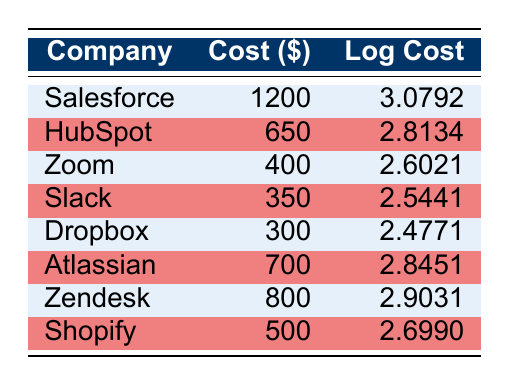What is the customer acquisition cost for Salesforce? By referring to the table, we look for the row that includes Salesforce. The customer acquisition cost is listed directly under that company's name, which is $1200.
Answer: 1200 Which company has the lowest customer acquisition cost? We inspect the "Cost ($)" column across all companies to determine the lowest value. The smallest number listed is $300, associated with Dropbox.
Answer: Dropbox What is the difference between the customer acquisition costs of Zendesk and HubSpot? First, identify the costs for both companies: Zendesk has $800 and HubSpot has $650. The difference is calculated as $800 - $650 = $150.
Answer: 150 Is the customer acquisition cost for Slack higher than that of Zoom? We can compare the costs: Slack has $350, and Zoom has $400. Since $350 is not greater than $400, the answer is "No."
Answer: No What is the average customer acquisition cost of the companies listed? To calculate the average, we sum all the listed costs: 1200 (Salesforce) + 650 (HubSpot) + 400 (Zoom) + 350 (Slack) + 300 (Dropbox) + 700 (Atlassian) + 800 (Zendesk) + 500 (Shopify) = 3900. There are 8 companies, so the average is 3900 / 8 = 487.5.
Answer: 487.5 Which company has a logarithmic cost greater than 2.8? We need to filter the "Log Cost" column for values greater than 2.8. Salesforce (3.0792), Zendesk (2.9031), and Atlassian (2.8451) are above this threshold.
Answer: Salesforce, Zendesk, Atlassian What percentage of the highest customer acquisition cost does the lowest cost represent? The highest cost is $1200 (Salesforce), and the lowest is $300 (Dropbox). To find the percentage, we use the formula: (300 / 1200) * 100 = 25%.
Answer: 25 Is it true that Shopify's logarithmic cost is less than that of Zoom? Shopify has a logarithmic cost of 2.6990, whereas Zoom has a logarithmic cost of 2.6021. Since 2.6990 is greater than 2.6021, the statement is false.
Answer: No What is the sum of customer acquisition costs for companies with a cost less than $500? We identify the companies with costs less than $500: Zoom ($400), Slack ($350), Dropbox ($300), and Shopify ($500). Then we sum these: 400 + 350 + 300 + 500 = 1550.
Answer: 1550 